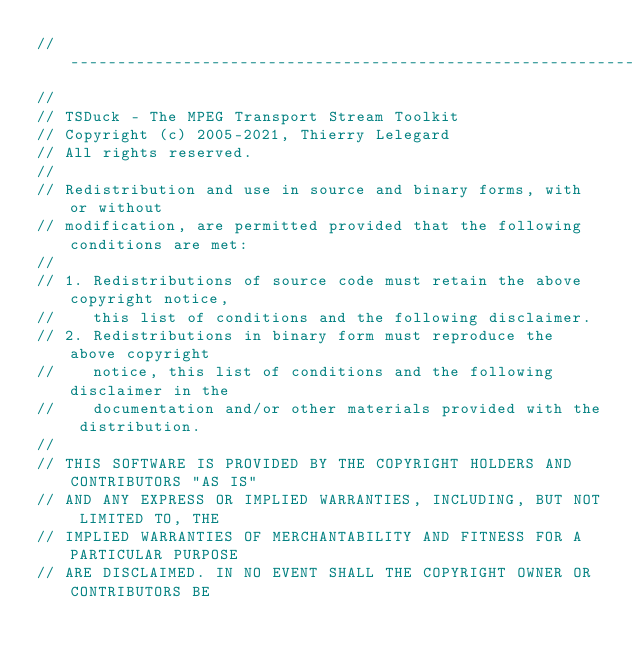<code> <loc_0><loc_0><loc_500><loc_500><_C++_>//----------------------------------------------------------------------------
//
// TSDuck - The MPEG Transport Stream Toolkit
// Copyright (c) 2005-2021, Thierry Lelegard
// All rights reserved.
//
// Redistribution and use in source and binary forms, with or without
// modification, are permitted provided that the following conditions are met:
//
// 1. Redistributions of source code must retain the above copyright notice,
//    this list of conditions and the following disclaimer.
// 2. Redistributions in binary form must reproduce the above copyright
//    notice, this list of conditions and the following disclaimer in the
//    documentation and/or other materials provided with the distribution.
//
// THIS SOFTWARE IS PROVIDED BY THE COPYRIGHT HOLDERS AND CONTRIBUTORS "AS IS"
// AND ANY EXPRESS OR IMPLIED WARRANTIES, INCLUDING, BUT NOT LIMITED TO, THE
// IMPLIED WARRANTIES OF MERCHANTABILITY AND FITNESS FOR A PARTICULAR PURPOSE
// ARE DISCLAIMED. IN NO EVENT SHALL THE COPYRIGHT OWNER OR CONTRIBUTORS BE</code> 